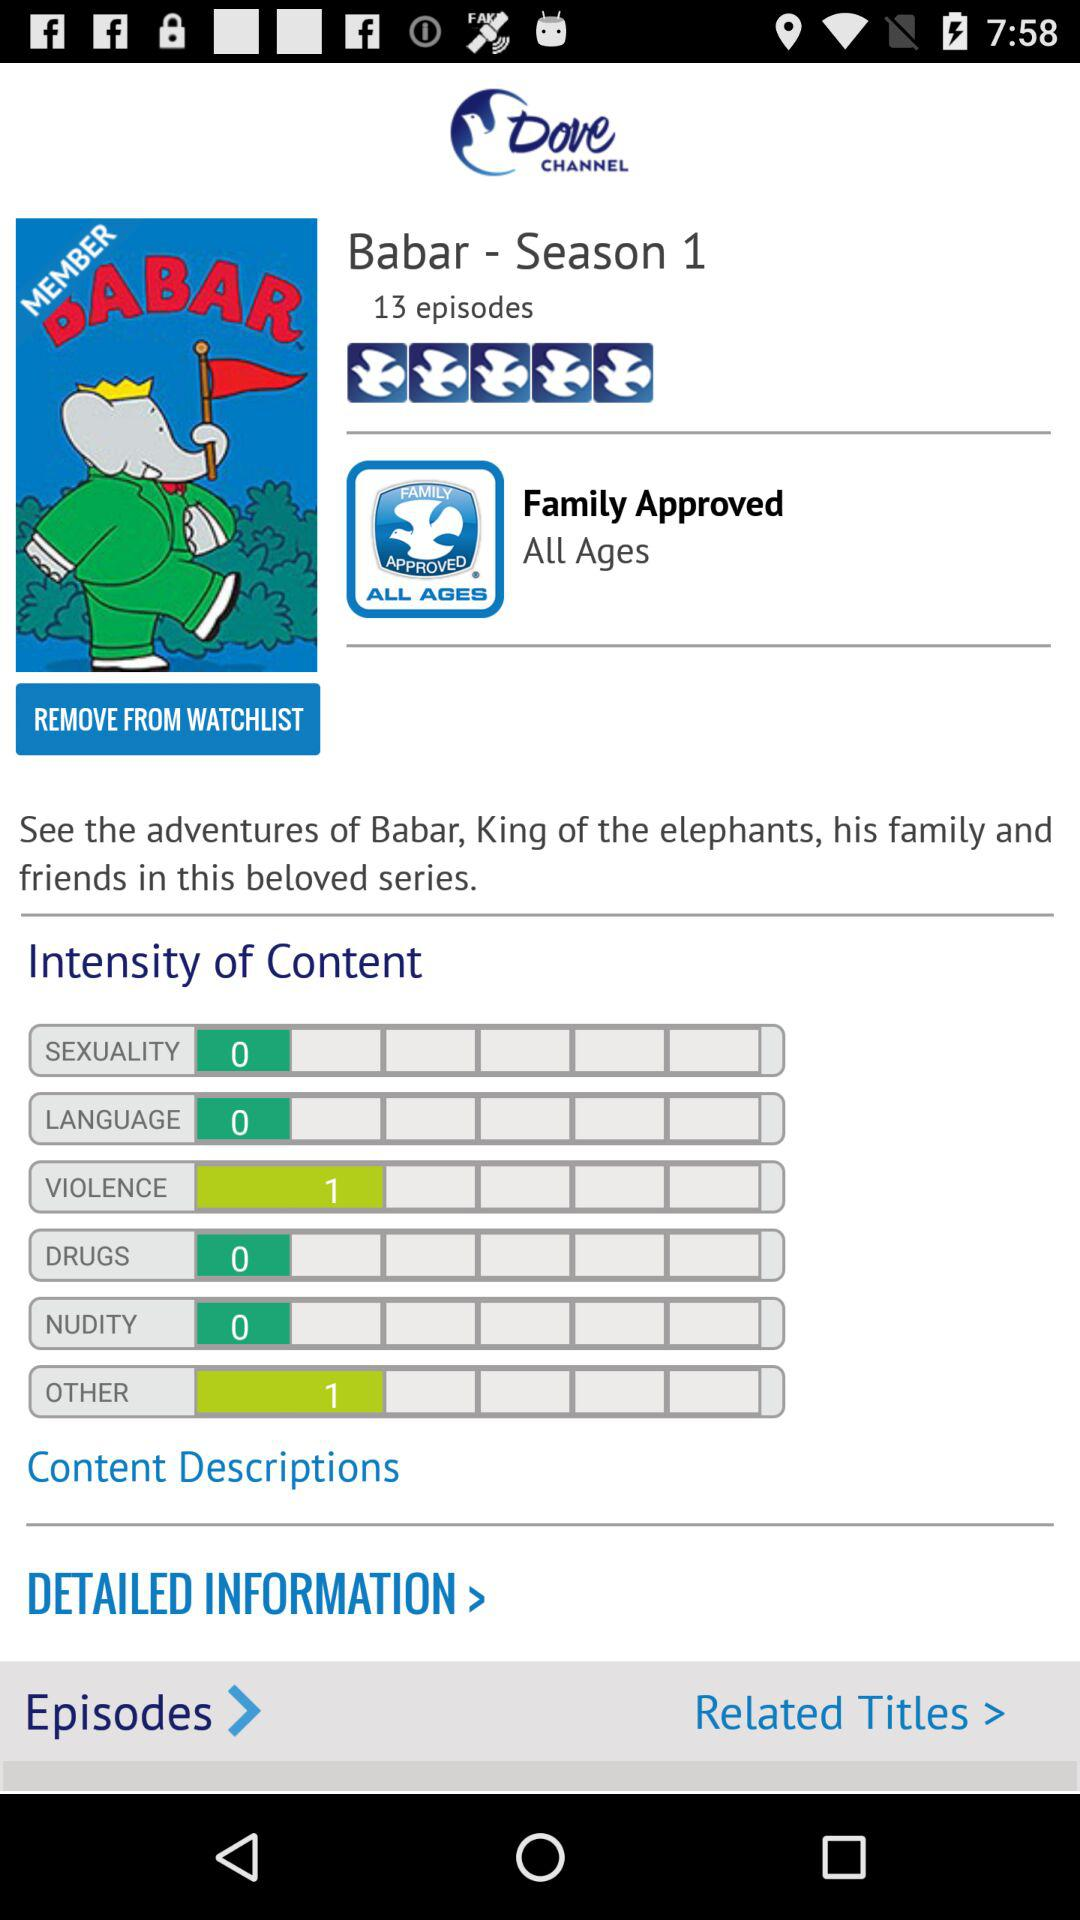What is the description of the series? The description of the series is "See the adventures of Babar, King of the elephants, his family and friends in this beloved series.". 